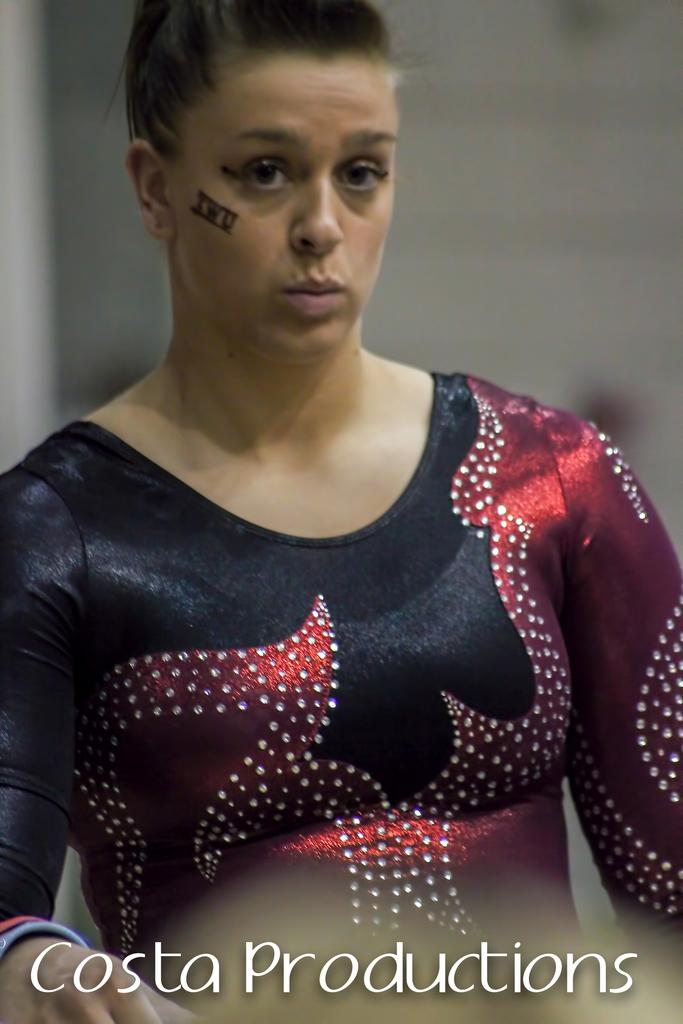Who is the main subject in the image? There is a woman in the image. What is the woman wearing? The woman is wearing a black and maroon dress. Can you describe the background of the image? The background of the image is blurred. Is there any additional information or markings on the image? Yes, there is a watermark at the bottom of the image. What type of zinc can be seen in the woman's hands in the image? There is no zinc present in the image, and the woman's hands are not visible. How many cats are sitting on the woman's lap in the image? There are no cats present in the image, and the woman's lap is not visible. 